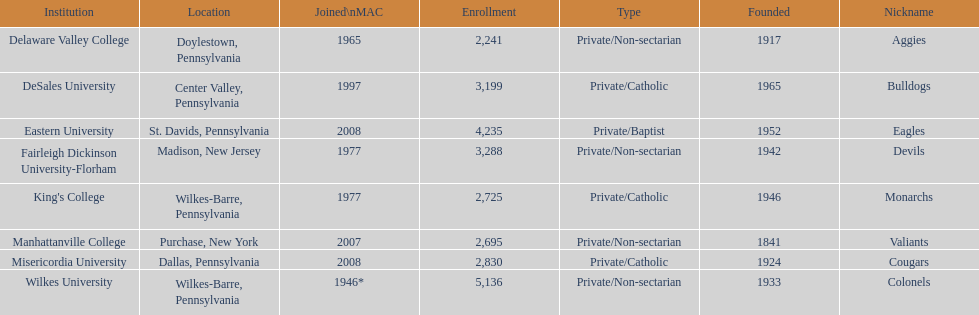Name each institution with enrollment numbers above 4,000? Eastern University, Wilkes University. 